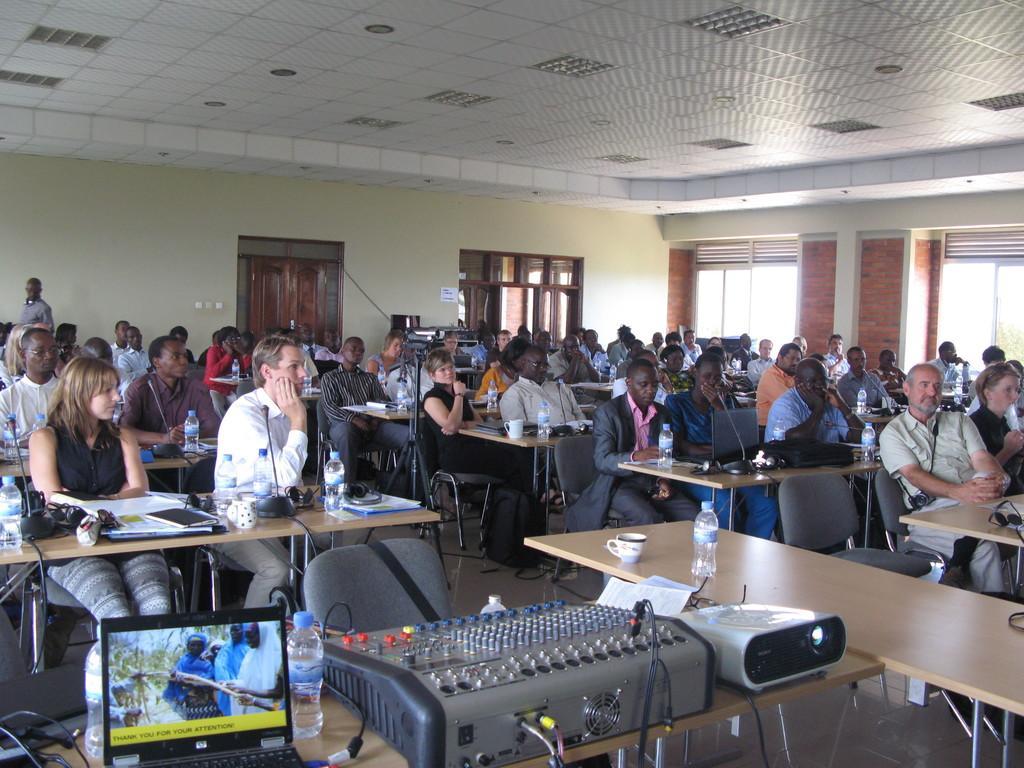In one or two sentences, can you explain what this image depicts? In this image there are group of people sitting in chair ,near the table , and in table there are book , paper, bottle, laptop, mouse , and in the background there is a cup , bottle in table , door, light , window. 